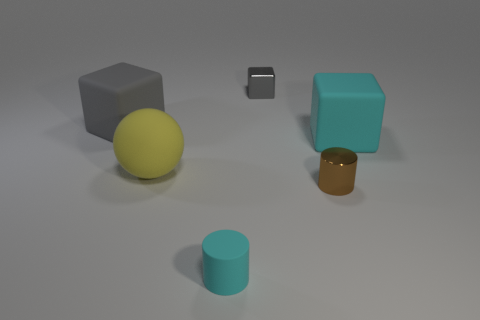Subtract all brown cylinders. Subtract all blue spheres. How many cylinders are left? 1 Add 3 large yellow matte things. How many objects exist? 9 Subtract all cylinders. How many objects are left? 4 Add 2 red cylinders. How many red cylinders exist? 2 Subtract 1 brown cylinders. How many objects are left? 5 Subtract all rubber things. Subtract all big gray things. How many objects are left? 1 Add 2 large gray rubber objects. How many large gray rubber objects are left? 3 